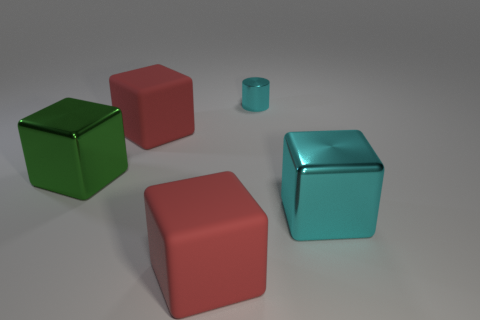Subtract 1 blocks. How many blocks are left? 3 Add 2 rubber cylinders. How many objects exist? 7 Subtract all blocks. How many objects are left? 1 Subtract 1 cyan cylinders. How many objects are left? 4 Subtract all big things. Subtract all large cyan metallic blocks. How many objects are left? 0 Add 1 red rubber cubes. How many red rubber cubes are left? 3 Add 2 tiny cyan shiny cylinders. How many tiny cyan shiny cylinders exist? 3 